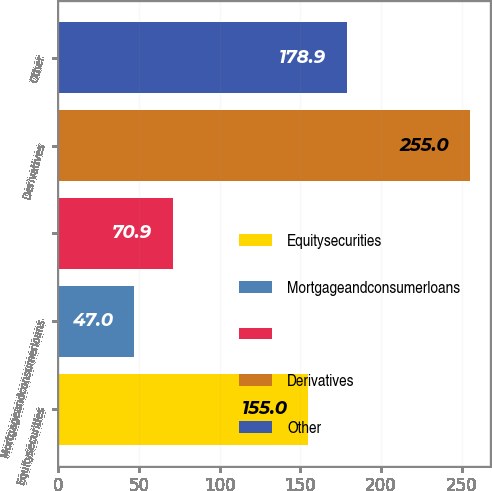Convert chart. <chart><loc_0><loc_0><loc_500><loc_500><bar_chart><fcel>Equitysecurities<fcel>Mortgageandconsumerloans<fcel>Unnamed: 2<fcel>Derivatives<fcel>Other<nl><fcel>155<fcel>47<fcel>70.9<fcel>255<fcel>178.9<nl></chart> 